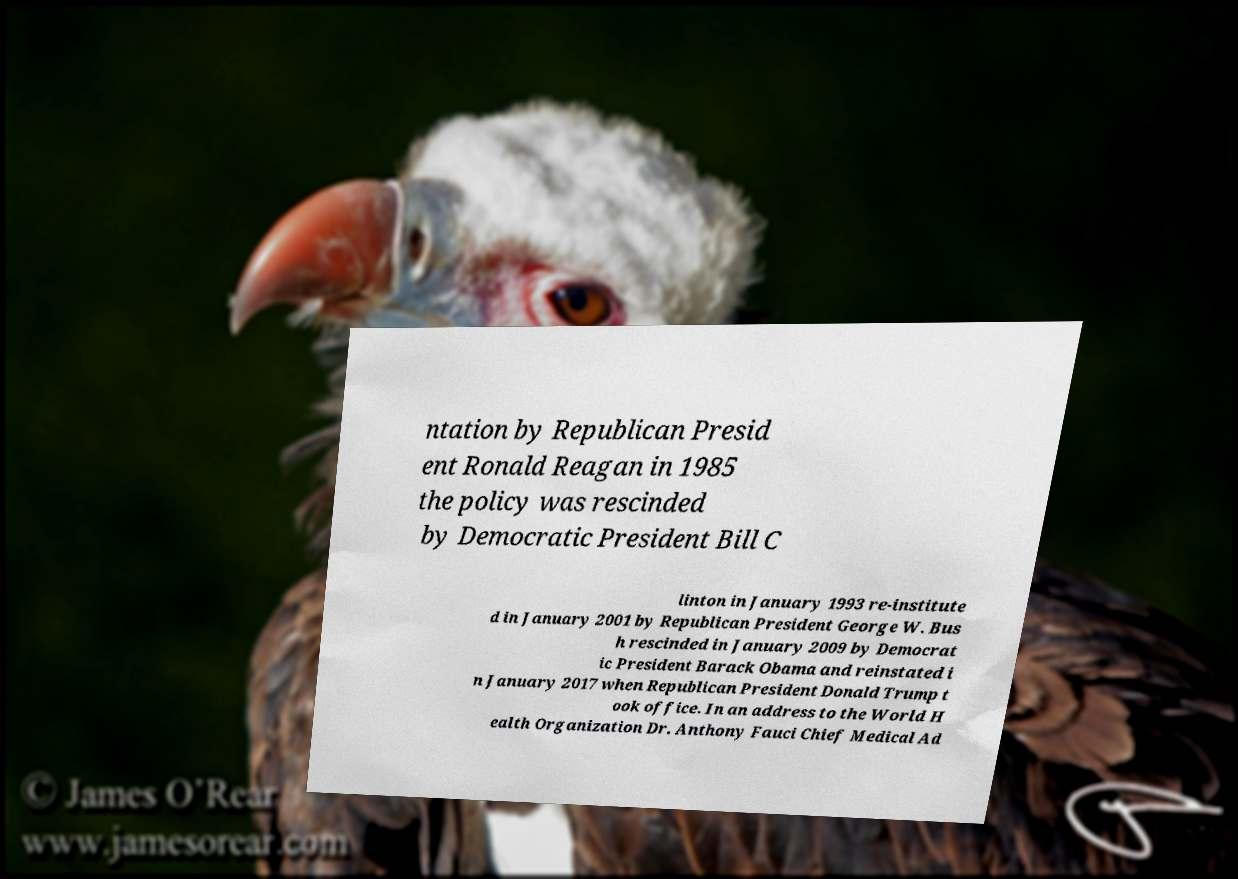Can you read and provide the text displayed in the image?This photo seems to have some interesting text. Can you extract and type it out for me? ntation by Republican Presid ent Ronald Reagan in 1985 the policy was rescinded by Democratic President Bill C linton in January 1993 re-institute d in January 2001 by Republican President George W. Bus h rescinded in January 2009 by Democrat ic President Barack Obama and reinstated i n January 2017 when Republican President Donald Trump t ook office. In an address to the World H ealth Organization Dr. Anthony Fauci Chief Medical Ad 